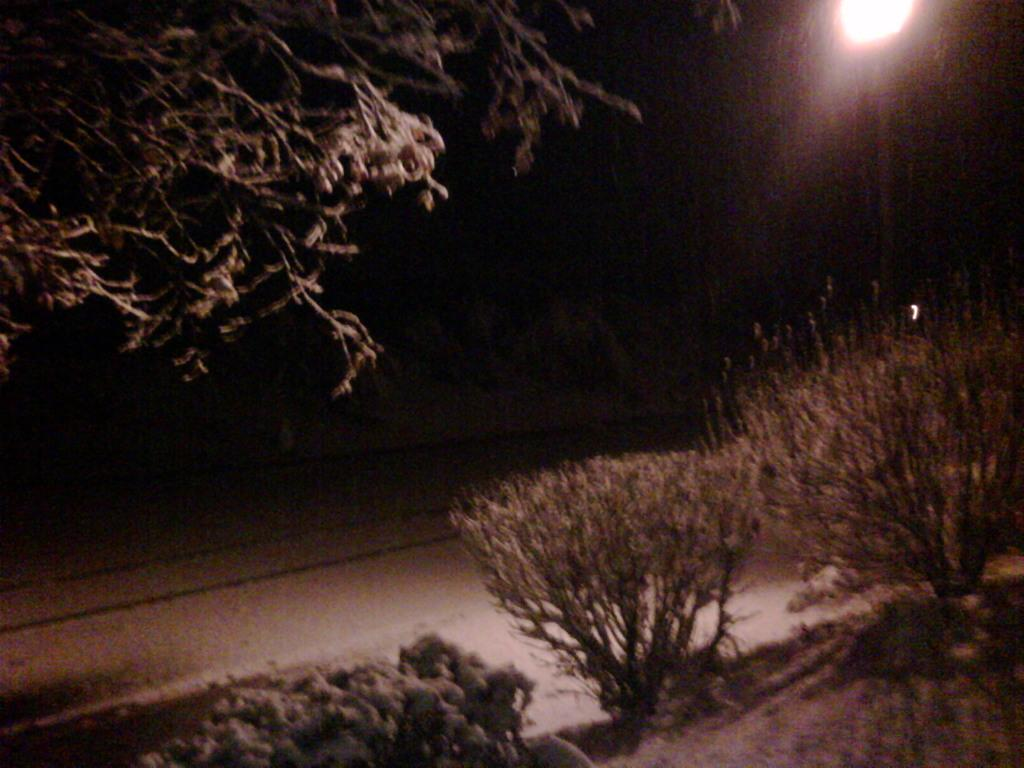What time of day is depicted in the image? The image depicts a night view. What can be seen in the image besides the night view? There is a street and a street light present in the image. Are there any plants visible in the image? Yes, there are bushes in the image. How many letters are being used to spell out a word on the street in the image? There are no letters or words visible on the street in the image. What type of sticks can be seen in the image? There are no sticks present in the image. 